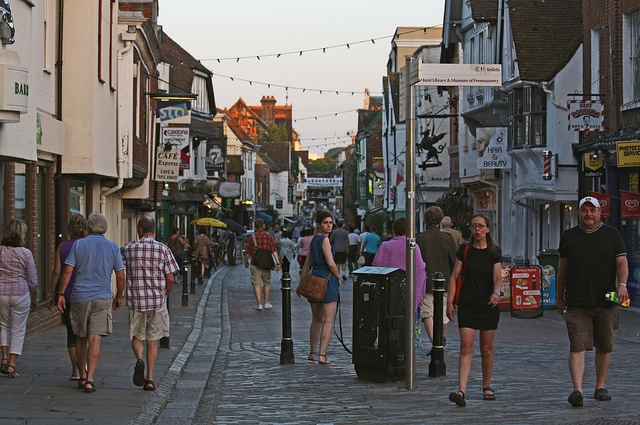Describe the objects in this image and their specific colors. I can see people in black, maroon, gray, and brown tones, people in black, gray, and maroon tones, people in black, maroon, brown, and gray tones, people in black, gray, darkgray, and maroon tones, and people in black and gray tones in this image. 